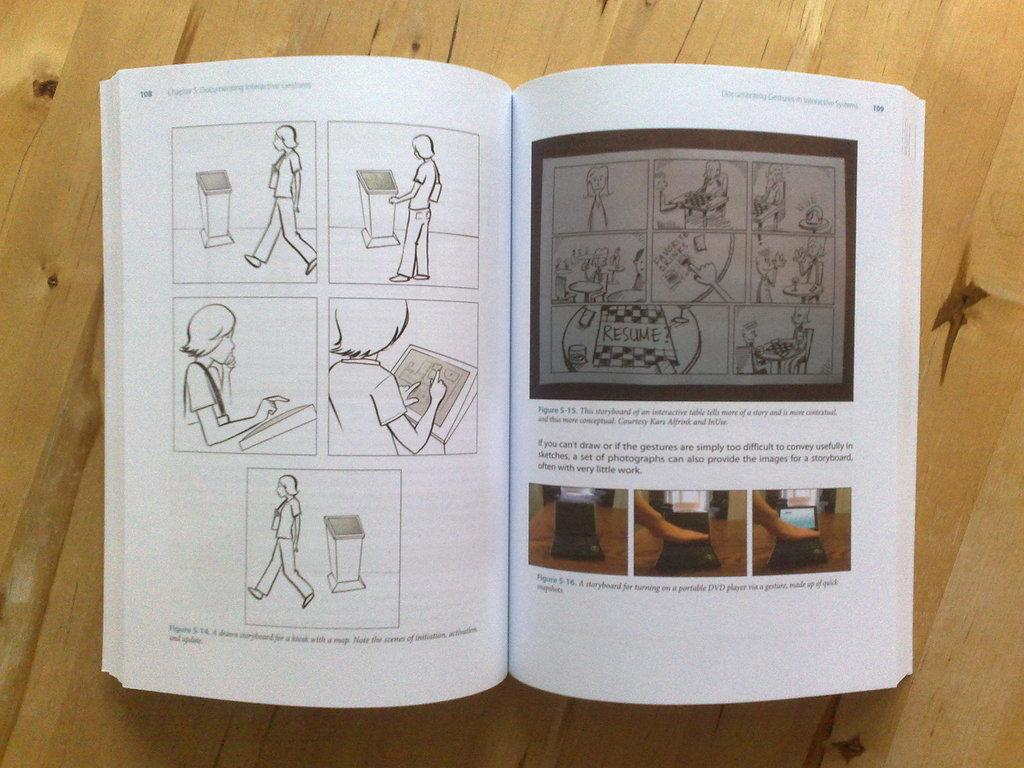Provide a one-sentence caption for the provided image. Book that has pictures and says page 108 on it. 